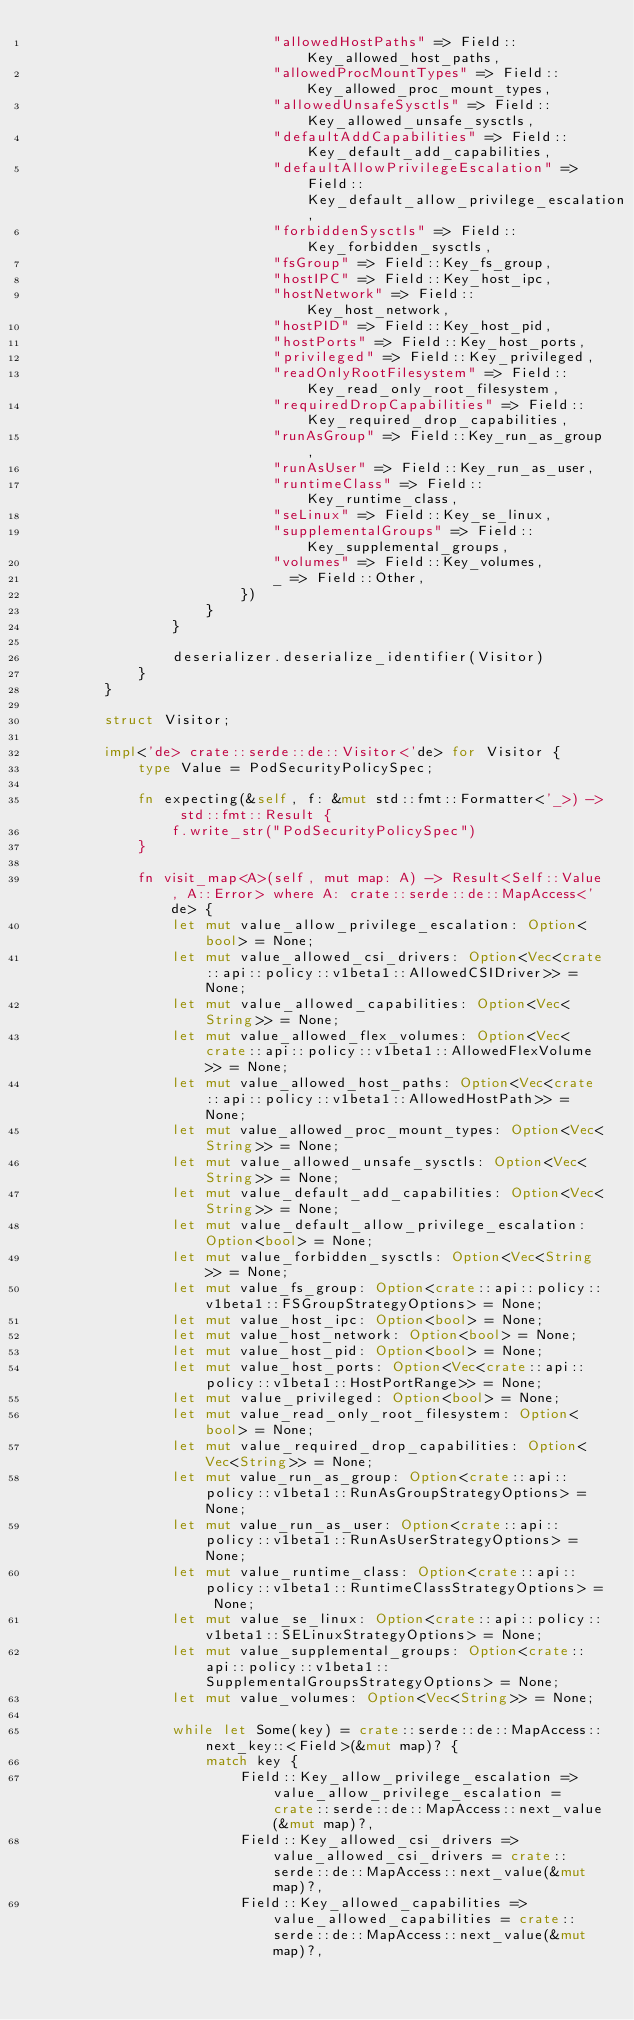<code> <loc_0><loc_0><loc_500><loc_500><_Rust_>                            "allowedHostPaths" => Field::Key_allowed_host_paths,
                            "allowedProcMountTypes" => Field::Key_allowed_proc_mount_types,
                            "allowedUnsafeSysctls" => Field::Key_allowed_unsafe_sysctls,
                            "defaultAddCapabilities" => Field::Key_default_add_capabilities,
                            "defaultAllowPrivilegeEscalation" => Field::Key_default_allow_privilege_escalation,
                            "forbiddenSysctls" => Field::Key_forbidden_sysctls,
                            "fsGroup" => Field::Key_fs_group,
                            "hostIPC" => Field::Key_host_ipc,
                            "hostNetwork" => Field::Key_host_network,
                            "hostPID" => Field::Key_host_pid,
                            "hostPorts" => Field::Key_host_ports,
                            "privileged" => Field::Key_privileged,
                            "readOnlyRootFilesystem" => Field::Key_read_only_root_filesystem,
                            "requiredDropCapabilities" => Field::Key_required_drop_capabilities,
                            "runAsGroup" => Field::Key_run_as_group,
                            "runAsUser" => Field::Key_run_as_user,
                            "runtimeClass" => Field::Key_runtime_class,
                            "seLinux" => Field::Key_se_linux,
                            "supplementalGroups" => Field::Key_supplemental_groups,
                            "volumes" => Field::Key_volumes,
                            _ => Field::Other,
                        })
                    }
                }

                deserializer.deserialize_identifier(Visitor)
            }
        }

        struct Visitor;

        impl<'de> crate::serde::de::Visitor<'de> for Visitor {
            type Value = PodSecurityPolicySpec;

            fn expecting(&self, f: &mut std::fmt::Formatter<'_>) -> std::fmt::Result {
                f.write_str("PodSecurityPolicySpec")
            }

            fn visit_map<A>(self, mut map: A) -> Result<Self::Value, A::Error> where A: crate::serde::de::MapAccess<'de> {
                let mut value_allow_privilege_escalation: Option<bool> = None;
                let mut value_allowed_csi_drivers: Option<Vec<crate::api::policy::v1beta1::AllowedCSIDriver>> = None;
                let mut value_allowed_capabilities: Option<Vec<String>> = None;
                let mut value_allowed_flex_volumes: Option<Vec<crate::api::policy::v1beta1::AllowedFlexVolume>> = None;
                let mut value_allowed_host_paths: Option<Vec<crate::api::policy::v1beta1::AllowedHostPath>> = None;
                let mut value_allowed_proc_mount_types: Option<Vec<String>> = None;
                let mut value_allowed_unsafe_sysctls: Option<Vec<String>> = None;
                let mut value_default_add_capabilities: Option<Vec<String>> = None;
                let mut value_default_allow_privilege_escalation: Option<bool> = None;
                let mut value_forbidden_sysctls: Option<Vec<String>> = None;
                let mut value_fs_group: Option<crate::api::policy::v1beta1::FSGroupStrategyOptions> = None;
                let mut value_host_ipc: Option<bool> = None;
                let mut value_host_network: Option<bool> = None;
                let mut value_host_pid: Option<bool> = None;
                let mut value_host_ports: Option<Vec<crate::api::policy::v1beta1::HostPortRange>> = None;
                let mut value_privileged: Option<bool> = None;
                let mut value_read_only_root_filesystem: Option<bool> = None;
                let mut value_required_drop_capabilities: Option<Vec<String>> = None;
                let mut value_run_as_group: Option<crate::api::policy::v1beta1::RunAsGroupStrategyOptions> = None;
                let mut value_run_as_user: Option<crate::api::policy::v1beta1::RunAsUserStrategyOptions> = None;
                let mut value_runtime_class: Option<crate::api::policy::v1beta1::RuntimeClassStrategyOptions> = None;
                let mut value_se_linux: Option<crate::api::policy::v1beta1::SELinuxStrategyOptions> = None;
                let mut value_supplemental_groups: Option<crate::api::policy::v1beta1::SupplementalGroupsStrategyOptions> = None;
                let mut value_volumes: Option<Vec<String>> = None;

                while let Some(key) = crate::serde::de::MapAccess::next_key::<Field>(&mut map)? {
                    match key {
                        Field::Key_allow_privilege_escalation => value_allow_privilege_escalation = crate::serde::de::MapAccess::next_value(&mut map)?,
                        Field::Key_allowed_csi_drivers => value_allowed_csi_drivers = crate::serde::de::MapAccess::next_value(&mut map)?,
                        Field::Key_allowed_capabilities => value_allowed_capabilities = crate::serde::de::MapAccess::next_value(&mut map)?,</code> 